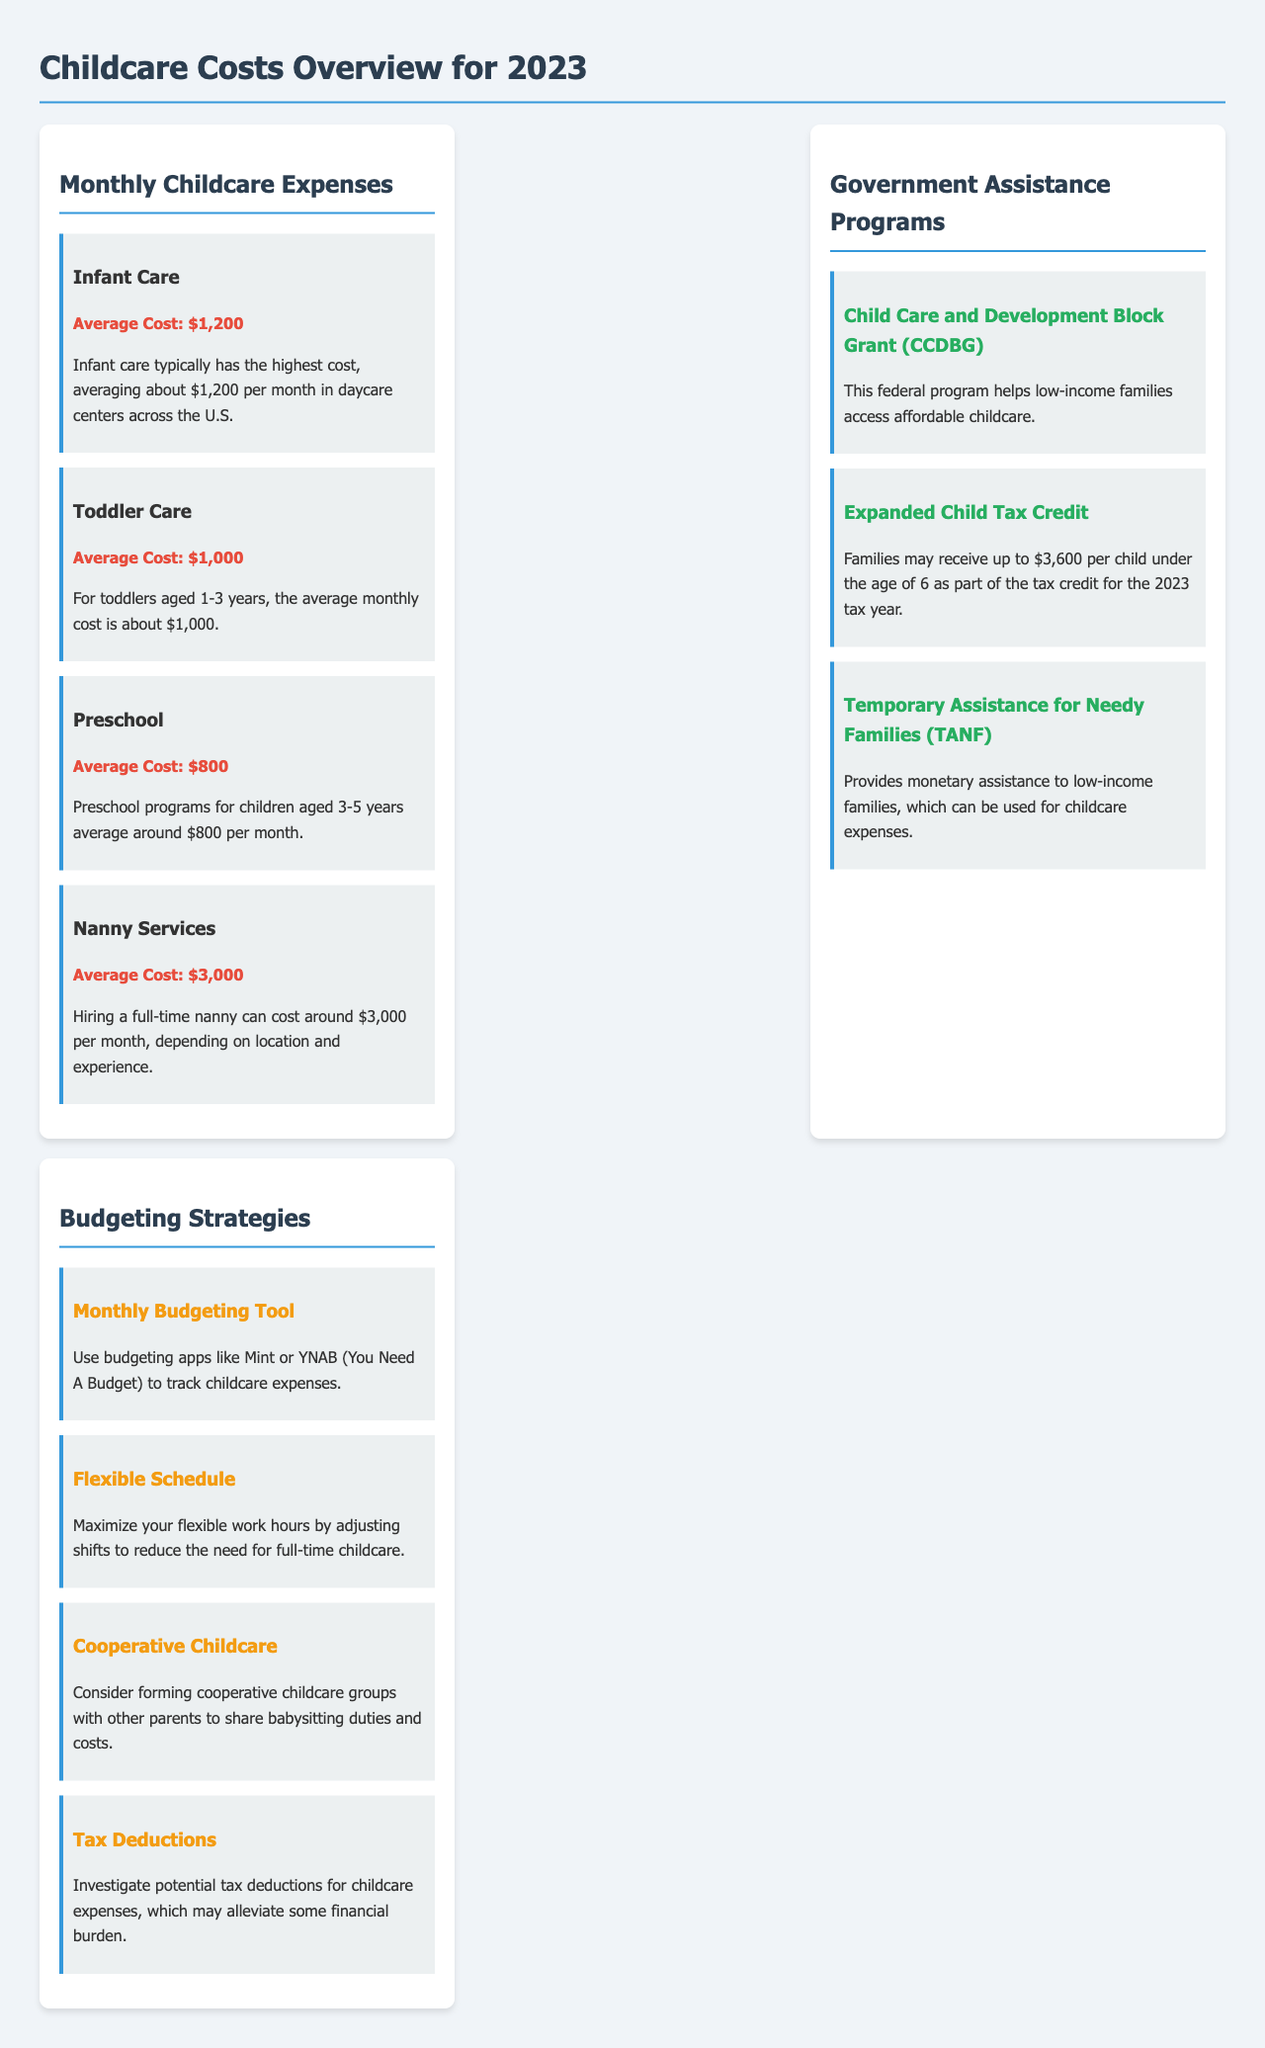What is the average cost of infant care? The average cost of infant care is mentioned as $1,200 per month in daycare centers across the U.S.
Answer: $1,200 What amount can families receive under the Expanded Child Tax Credit? Families may receive up to $3,600 per child under the age of 6 as part of the tax credit for the 2023 tax year.
Answer: $3,600 What is one budgeting tool suggested in the document? The document suggests using budgeting apps like Mint or YNAB (You Need A Budget) to track childcare expenses.
Answer: Mint or YNAB Which childcare option has the highest average cost? The document states that hiring a full-time nanny has the highest average cost.
Answer: Nanny Services How much does toddler care average per month? The monthly average cost for toddler care is about $1,000.
Answer: $1,000 What is a recommended strategy for managing childcare hours flexibly? One strategy is to maximize your flexible work hours by adjusting shifts to reduce the need for full-time childcare.
Answer: Flexible Schedule How many types of government assistance programs are listed? The document lists three types of government assistance programs.
Answer: Three What is a suggested approach to share childcare costs? The document suggests considering forming cooperative childcare groups with other parents to share babysitting duties and costs.
Answer: Cooperative Childcare What program helps low-income families access affordable childcare? The Child Care and Development Block Grant (CCDBG) is a program that helps low-income families access affordable childcare.
Answer: CCDBG 